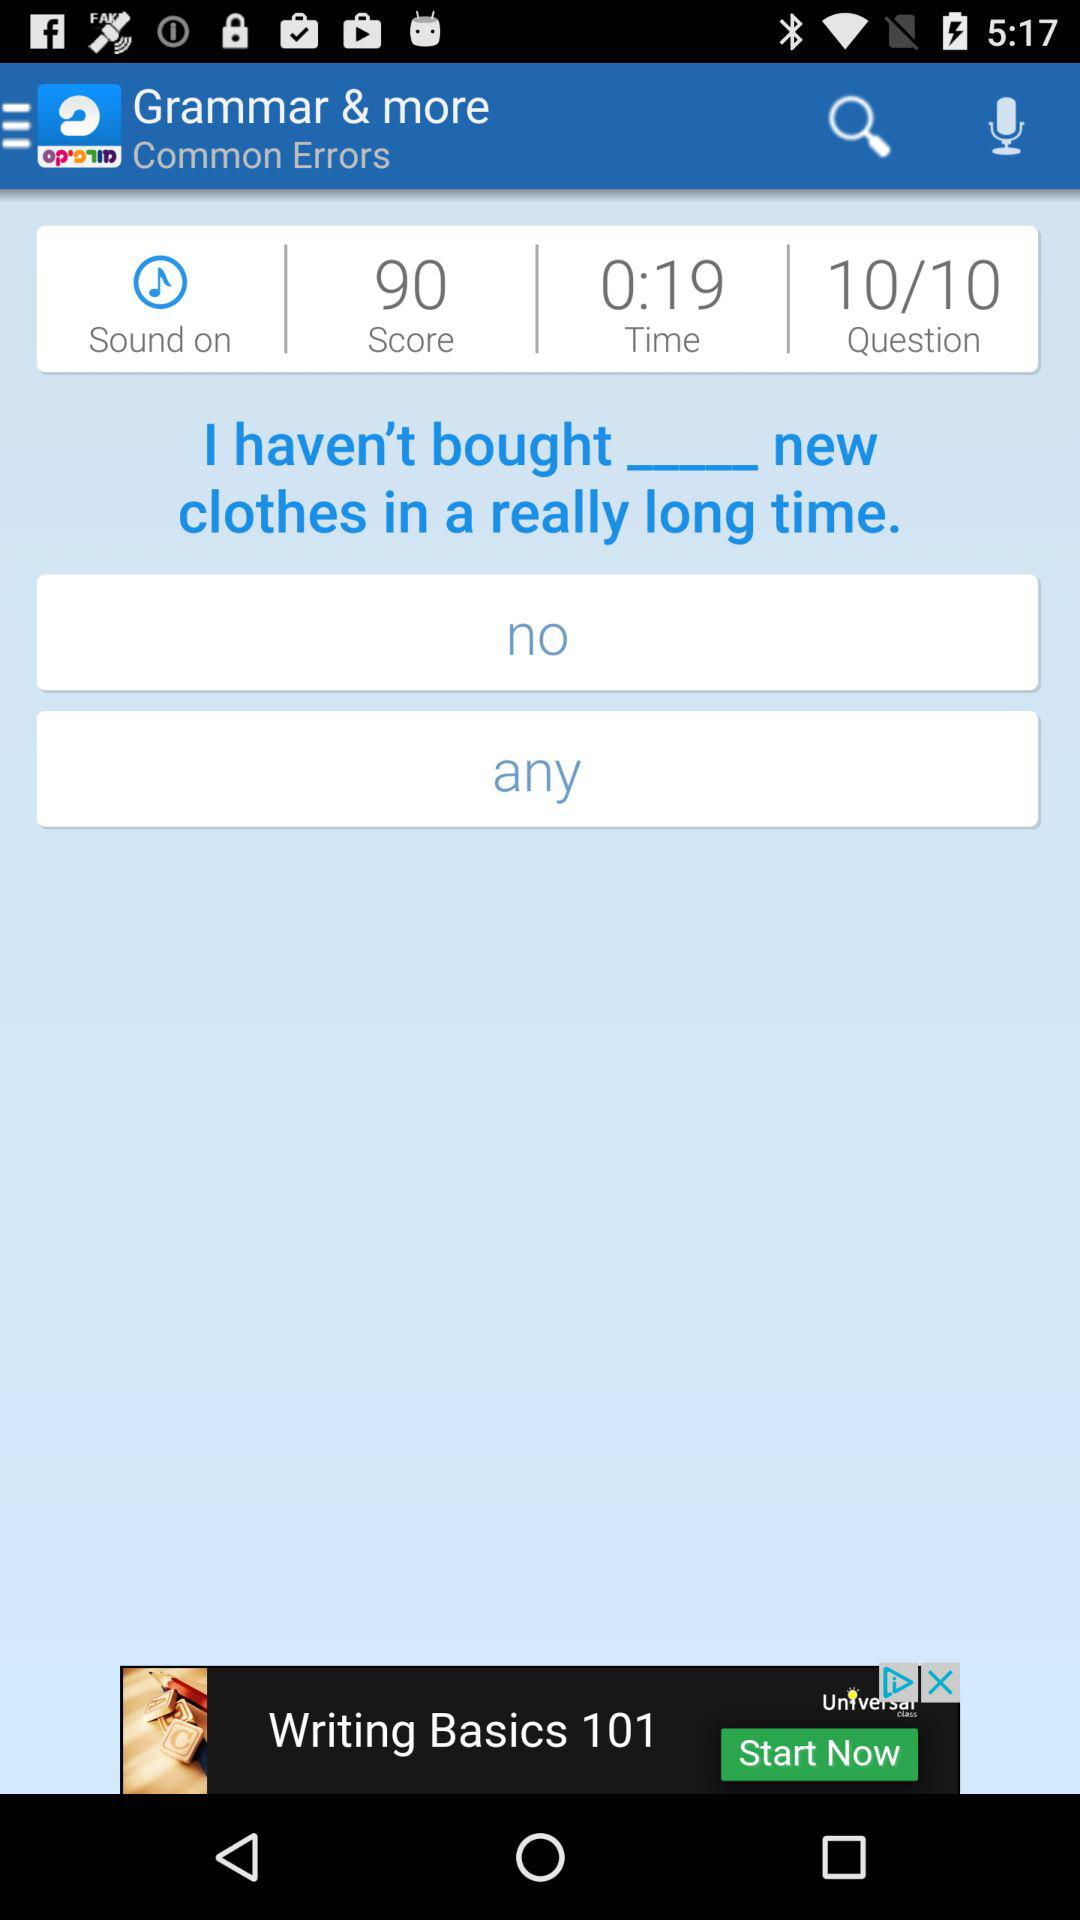What is the time? The time is 0:19. 